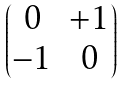Convert formula to latex. <formula><loc_0><loc_0><loc_500><loc_500>\begin{pmatrix} 0 & + 1 \\ - 1 & 0 \end{pmatrix}</formula> 